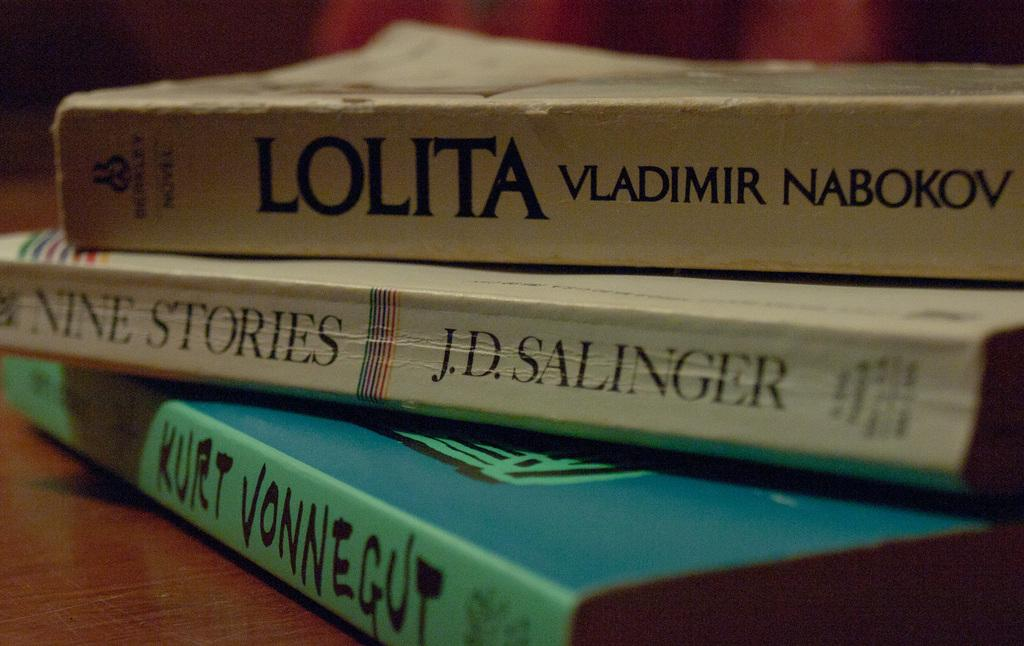How many books are on the table in the image? There are three books on the table in the image. What colors are the books on the table? The bottom book is in green color, the second book is in white color, and the first book is in grey color. What type of brass rail can be seen in the image? There is no brass rail present in the image. How many ducks are swimming in the water in the image? There is no water or ducks present in the image. 